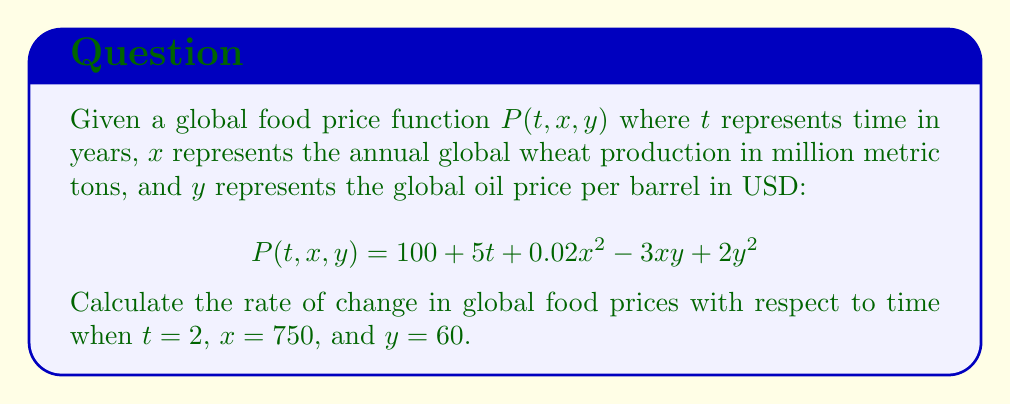Solve this math problem. To find the rate of change in global food prices with respect to time, we need to calculate the partial derivative of $P$ with respect to $t$ and then evaluate it at the given point.

Step 1: Calculate $\frac{\partial P}{\partial t}$
$$\frac{\partial P}{\partial t} = 5$$

Step 2: Evaluate $\frac{\partial P}{\partial t}$ at $t = 2$, $x = 750$, and $y = 60$
Since $\frac{\partial P}{\partial t}$ is constant and doesn't depend on $t$, $x$, or $y$, we don't need to substitute the values.

$$\frac{\partial P}{\partial t}\bigg|_{(2, 750, 60)} = 5$$

Therefore, the rate of change in global food prices with respect to time at the given point is 5 units per year.

Note: While the other variables ($x$ and $y$) don't affect the rate of change with respect to time in this case, they would be relevant when calculating the total rate of change using the total derivative:

$$\frac{dP}{dt} = \frac{\partial P}{\partial t} + \frac{\partial P}{\partial x}\frac{dx}{dt} + \frac{\partial P}{\partial y}\frac{dy}{dt}$$

This formula considers how changes in wheat production and oil prices over time might affect the overall rate of change in food prices.
Answer: 5 units per year 